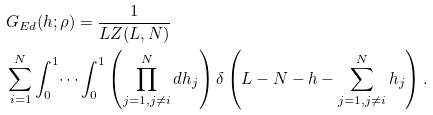<formula> <loc_0><loc_0><loc_500><loc_500>& G _ { E d } ( h ; \rho ) = \frac { 1 } { L Z ( L , N ) } \\ & \sum _ { i = 1 } ^ { N } \int _ { 0 } ^ { 1 } \dots \int _ { 0 } ^ { 1 } \left ( \prod _ { j = 1 , j \neq i } ^ { N } d h _ { j } \right ) \delta \left ( L - N - h - \sum _ { j = 1 , j \neq i } ^ { N } h _ { j } \right ) .</formula> 